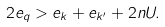<formula> <loc_0><loc_0><loc_500><loc_500>2 e _ { q } > e _ { k } + e _ { k ^ { \prime } } + 2 n U .</formula> 